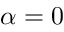Convert formula to latex. <formula><loc_0><loc_0><loc_500><loc_500>\alpha = 0</formula> 